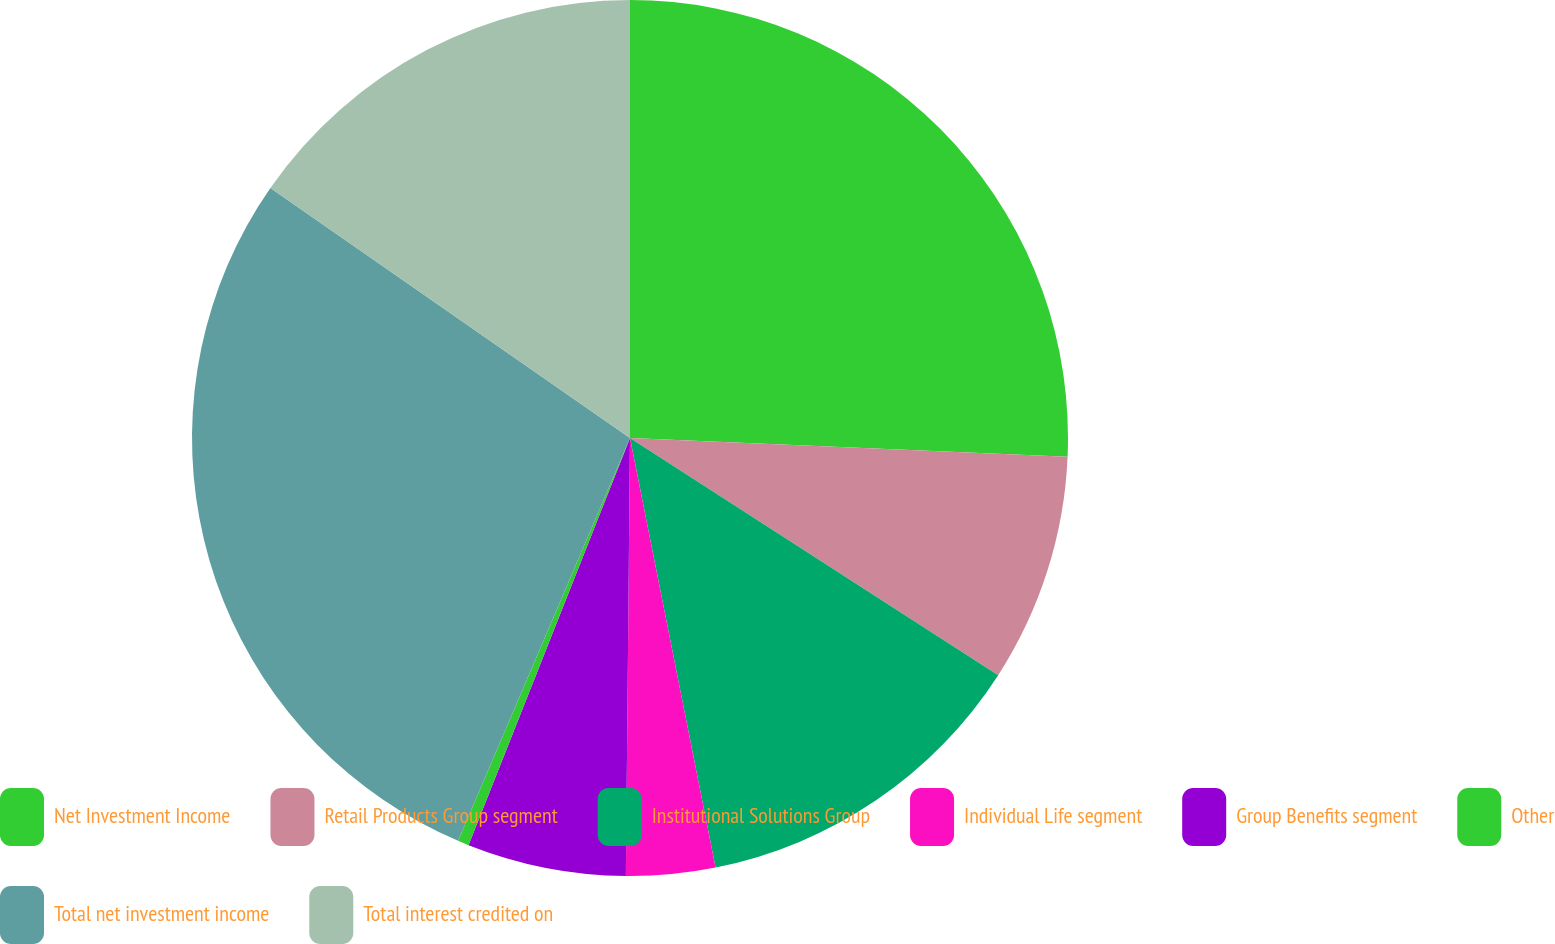Convert chart to OTSL. <chart><loc_0><loc_0><loc_500><loc_500><pie_chart><fcel>Net Investment Income<fcel>Retail Products Group segment<fcel>Institutional Solutions Group<fcel>Individual Life segment<fcel>Group Benefits segment<fcel>Other<fcel>Total net investment income<fcel>Total interest credited on<nl><fcel>25.68%<fcel>8.43%<fcel>12.76%<fcel>3.28%<fcel>5.86%<fcel>0.41%<fcel>28.25%<fcel>15.33%<nl></chart> 